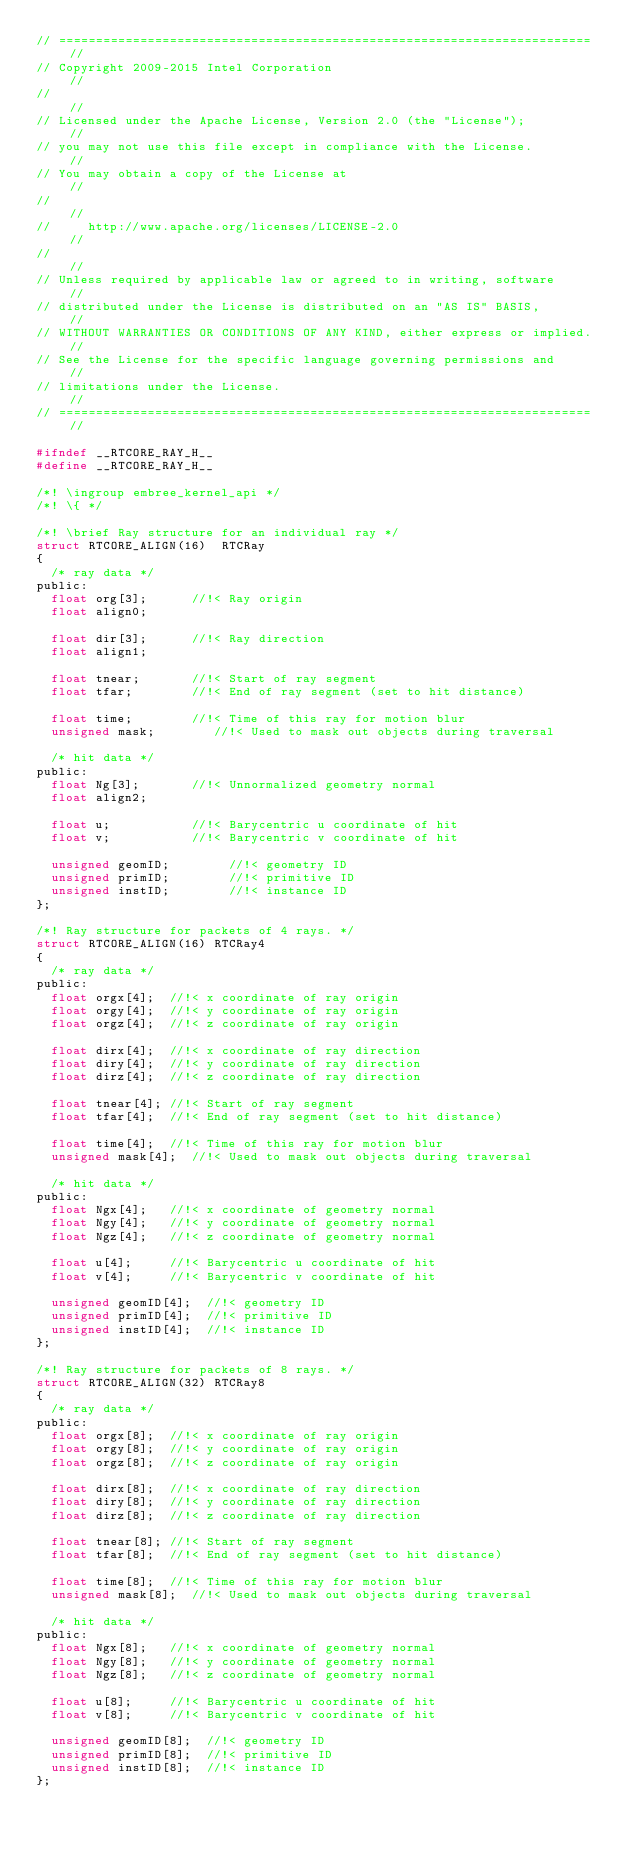<code> <loc_0><loc_0><loc_500><loc_500><_C_>// ======================================================================== //
// Copyright 2009-2015 Intel Corporation                                    //
//                                                                          //
// Licensed under the Apache License, Version 2.0 (the "License");          //
// you may not use this file except in compliance with the License.         //
// You may obtain a copy of the License at                                  //
//                                                                          //
//     http://www.apache.org/licenses/LICENSE-2.0                           //
//                                                                          //
// Unless required by applicable law or agreed to in writing, software      //
// distributed under the License is distributed on an "AS IS" BASIS,        //
// WITHOUT WARRANTIES OR CONDITIONS OF ANY KIND, either express or implied. //
// See the License for the specific language governing permissions and      //
// limitations under the License.                                           //
// ======================================================================== //

#ifndef __RTCORE_RAY_H__
#define __RTCORE_RAY_H__

/*! \ingroup embree_kernel_api */
/*! \{ */

/*! \brief Ray structure for an individual ray */
struct RTCORE_ALIGN(16)  RTCRay
{
  /* ray data */
public:
  float org[3];      //!< Ray origin
  float align0;
  
  float dir[3];      //!< Ray direction
  float align1;
  
  float tnear;       //!< Start of ray segment
  float tfar;        //!< End of ray segment (set to hit distance)

  float time;        //!< Time of this ray for motion blur
  unsigned mask;        //!< Used to mask out objects during traversal
  
  /* hit data */
public:
  float Ng[3];       //!< Unnormalized geometry normal
  float align2;
  
  float u;           //!< Barycentric u coordinate of hit
  float v;           //!< Barycentric v coordinate of hit

  unsigned geomID;        //!< geometry ID
  unsigned primID;        //!< primitive ID
  unsigned instID;        //!< instance ID
};

/*! Ray structure for packets of 4 rays. */
struct RTCORE_ALIGN(16) RTCRay4
{
  /* ray data */
public:
  float orgx[4];  //!< x coordinate of ray origin
  float orgy[4];  //!< y coordinate of ray origin
  float orgz[4];  //!< z coordinate of ray origin
  
  float dirx[4];  //!< x coordinate of ray direction
  float diry[4];  //!< y coordinate of ray direction
  float dirz[4];  //!< z coordinate of ray direction
  
  float tnear[4]; //!< Start of ray segment 
  float tfar[4];  //!< End of ray segment (set to hit distance)

  float time[4];  //!< Time of this ray for motion blur
  unsigned mask[4];  //!< Used to mask out objects during traversal
  
  /* hit data */
public:
  float Ngx[4];   //!< x coordinate of geometry normal
  float Ngy[4];   //!< y coordinate of geometry normal
  float Ngz[4];   //!< z coordinate of geometry normal
  
  float u[4];     //!< Barycentric u coordinate of hit
  float v[4];     //!< Barycentric v coordinate of hit
  
  unsigned geomID[4];  //!< geometry ID
  unsigned primID[4];  //!< primitive ID
  unsigned instID[4];  //!< instance ID
};

/*! Ray structure for packets of 8 rays. */
struct RTCORE_ALIGN(32) RTCRay8
{
  /* ray data */
public:
  float orgx[8];  //!< x coordinate of ray origin
  float orgy[8];  //!< y coordinate of ray origin
  float orgz[8];  //!< z coordinate of ray origin
  
  float dirx[8];  //!< x coordinate of ray direction
  float diry[8];  //!< y coordinate of ray direction
  float dirz[8];  //!< z coordinate of ray direction
  
  float tnear[8]; //!< Start of ray segment 
  float tfar[8];  //!< End of ray segment (set to hit distance)

  float time[8];  //!< Time of this ray for motion blur
  unsigned mask[8];  //!< Used to mask out objects during traversal
  
  /* hit data */
public:
  float Ngx[8];   //!< x coordinate of geometry normal
  float Ngy[8];   //!< y coordinate of geometry normal
  float Ngz[8];   //!< z coordinate of geometry normal
  
  float u[8];     //!< Barycentric u coordinate of hit
  float v[8];     //!< Barycentric v coordinate of hit
  
  unsigned geomID[8];  //!< geometry ID
  unsigned primID[8];  //!< primitive ID
  unsigned instID[8];  //!< instance ID
};
</code> 